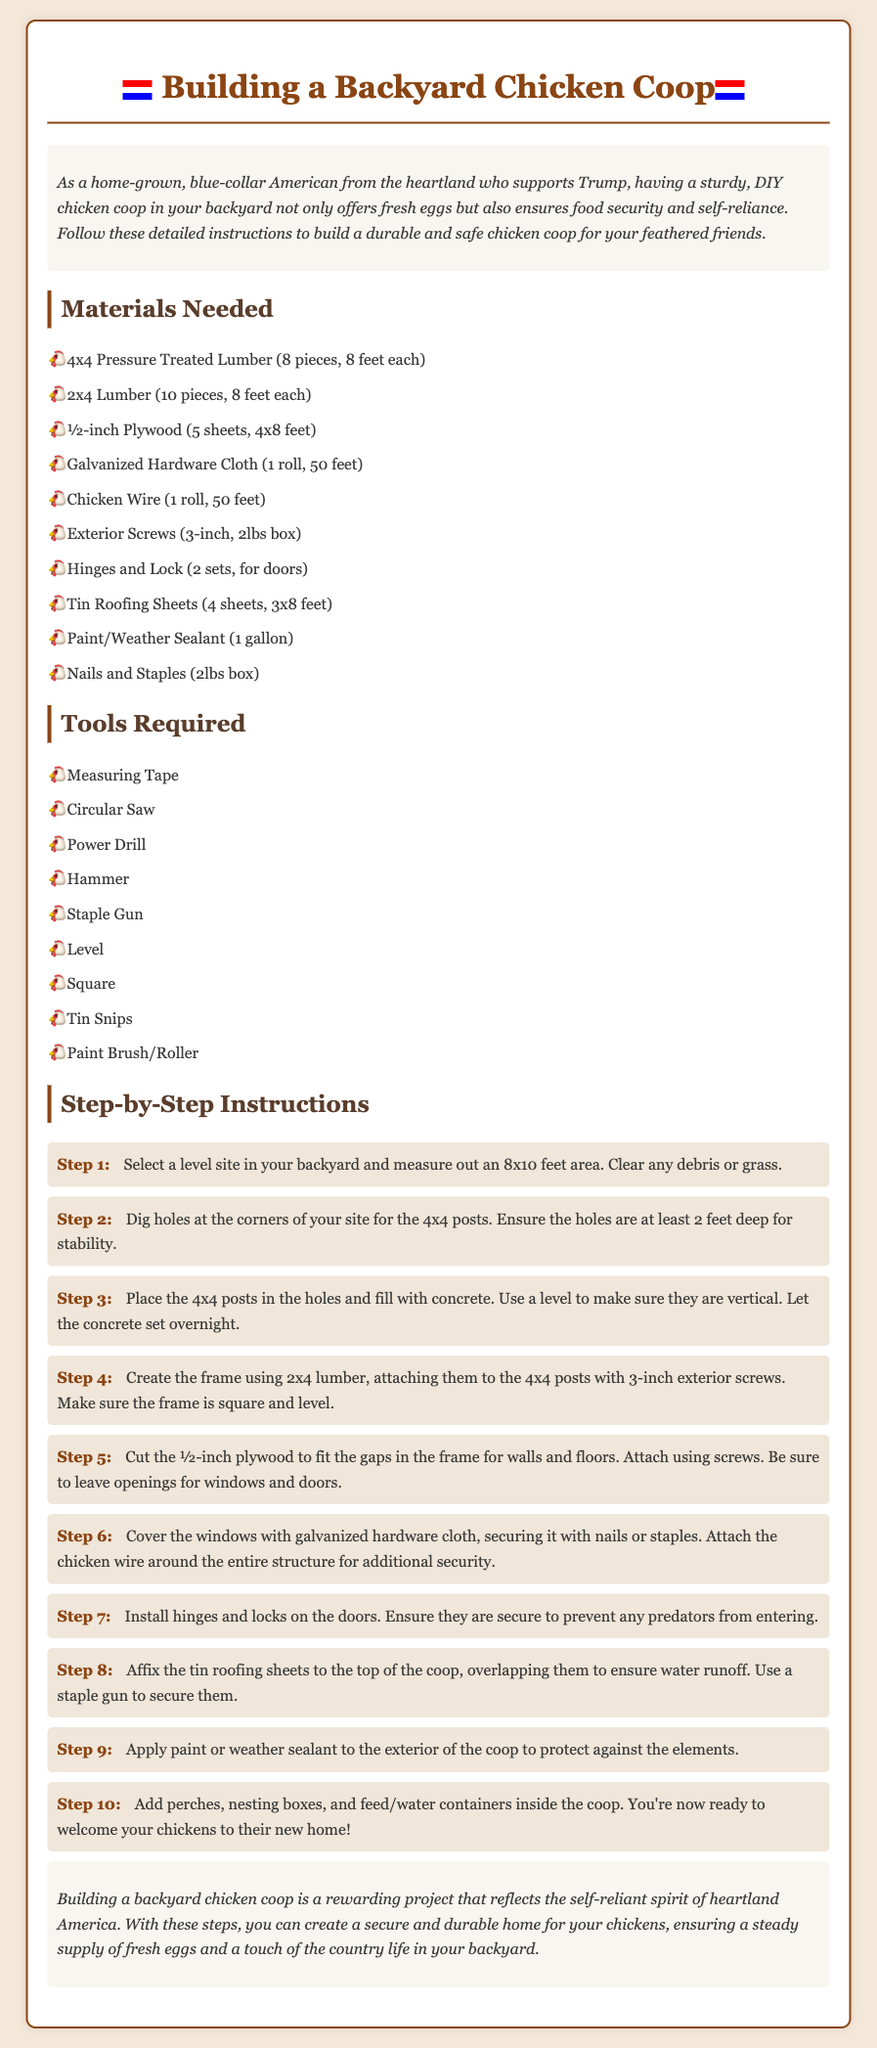What is the total number of 4x4 Pressure Treated Lumber pieces needed? The document states that 8 pieces of 4x4 Pressure Treated Lumber are required for the project.
Answer: 8 pieces How deep should the holes be for the 4x4 posts? The instructions specify that the holes for the 4x4 posts should be at least 2 feet deep to ensure stability.
Answer: 2 feet What material is used to cover the windows? The document indicates that windows should be covered with galvanized hardware cloth for security.
Answer: Galvanized hardware cloth Which tool is needed to cut the roofing sheets? The document lists Tin Snips as one of the tools required to cut the tin roofing sheets.
Answer: Tin Snips What is the size of the area that needs to be measured for the coop? The instructions mention that an area of 8x10 feet should be measured out for the chicken coop.
Answer: 8x10 feet How many steps are there in total to build the coop? The step-by-step instructions section details 10 specific steps for constructing the chicken coop.
Answer: 10 steps What should be applied to the exterior of the coop for protection? The instructions recommend applying paint or weather sealant to protect the coop from the elements.
Answer: Paint/Weather Sealant What do you need to ensure after placing the posts in the holes? The document emphasizes that it’s important to make sure the posts are vertical after placing them in the holes.
Answer: Vertical What is the purpose of adding nesting boxes inside the coop? The conclusion suggests that nesting boxes are essential to prepare for the chickens' arrival in their new home.
Answer: Welcoming chickens 